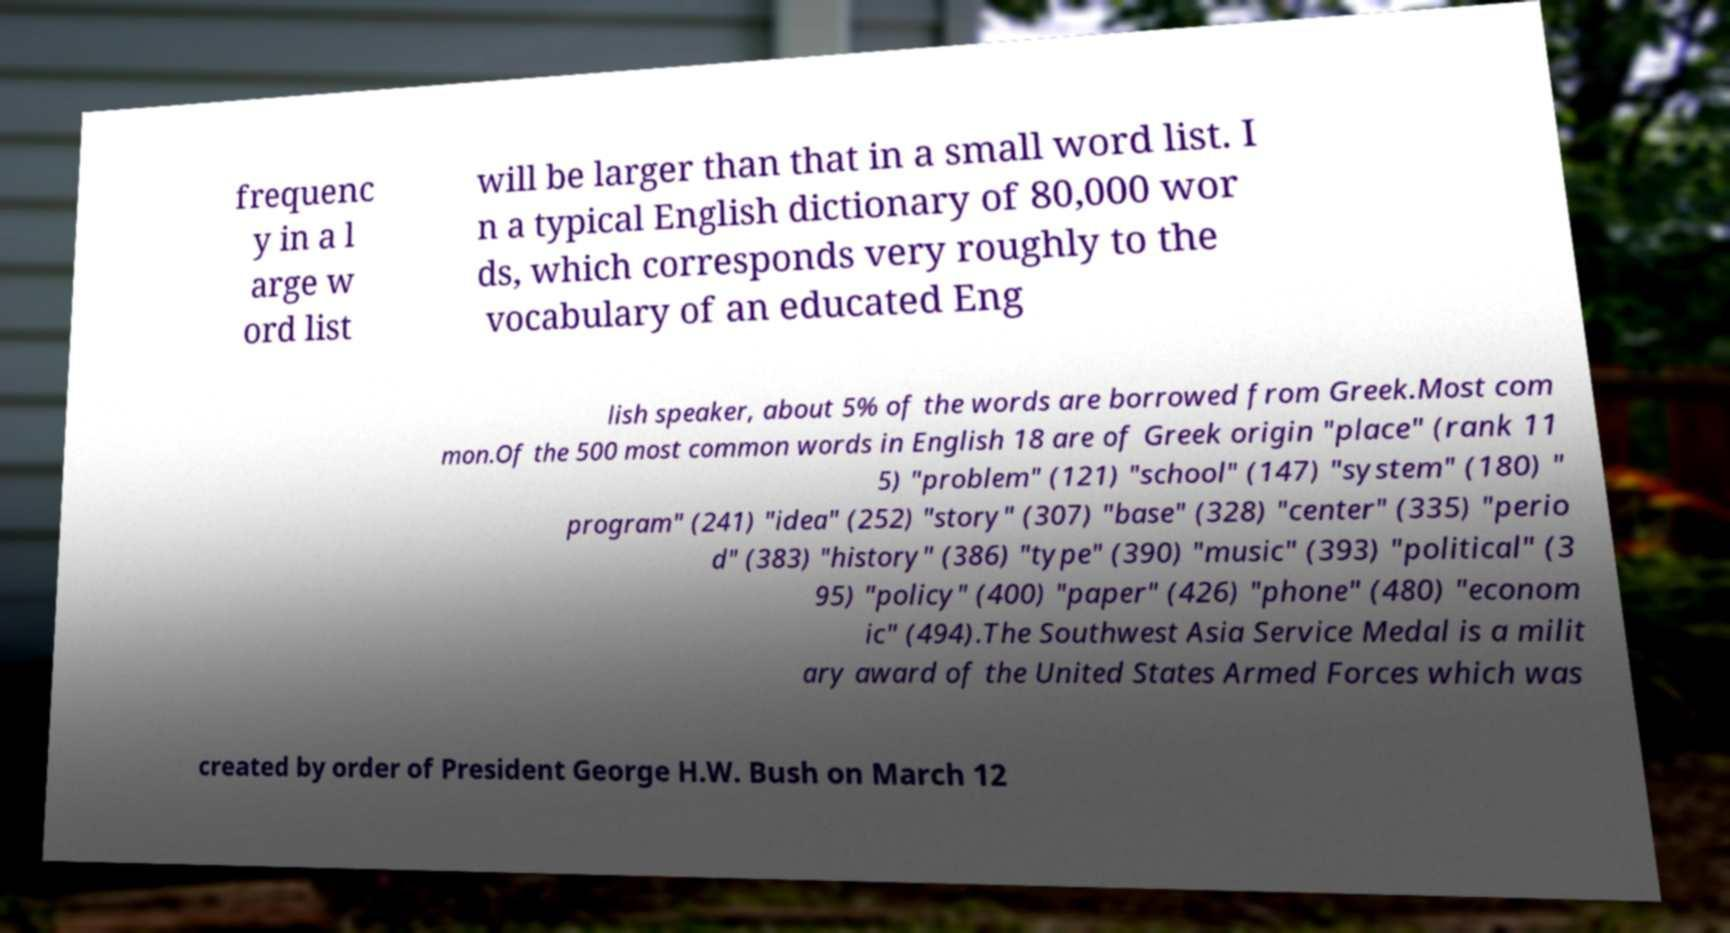Please read and relay the text visible in this image. What does it say? frequenc y in a l arge w ord list will be larger than that in a small word list. I n a typical English dictionary of 80,000 wor ds, which corresponds very roughly to the vocabulary of an educated Eng lish speaker, about 5% of the words are borrowed from Greek.Most com mon.Of the 500 most common words in English 18 are of Greek origin "place" (rank 11 5) "problem" (121) "school" (147) "system" (180) " program" (241) "idea" (252) "story" (307) "base" (328) "center" (335) "perio d" (383) "history" (386) "type" (390) "music" (393) "political" (3 95) "policy" (400) "paper" (426) "phone" (480) "econom ic" (494).The Southwest Asia Service Medal is a milit ary award of the United States Armed Forces which was created by order of President George H.W. Bush on March 12 